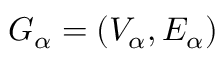Convert formula to latex. <formula><loc_0><loc_0><loc_500><loc_500>G _ { \alpha } = ( V _ { \alpha } , E _ { \alpha } )</formula> 